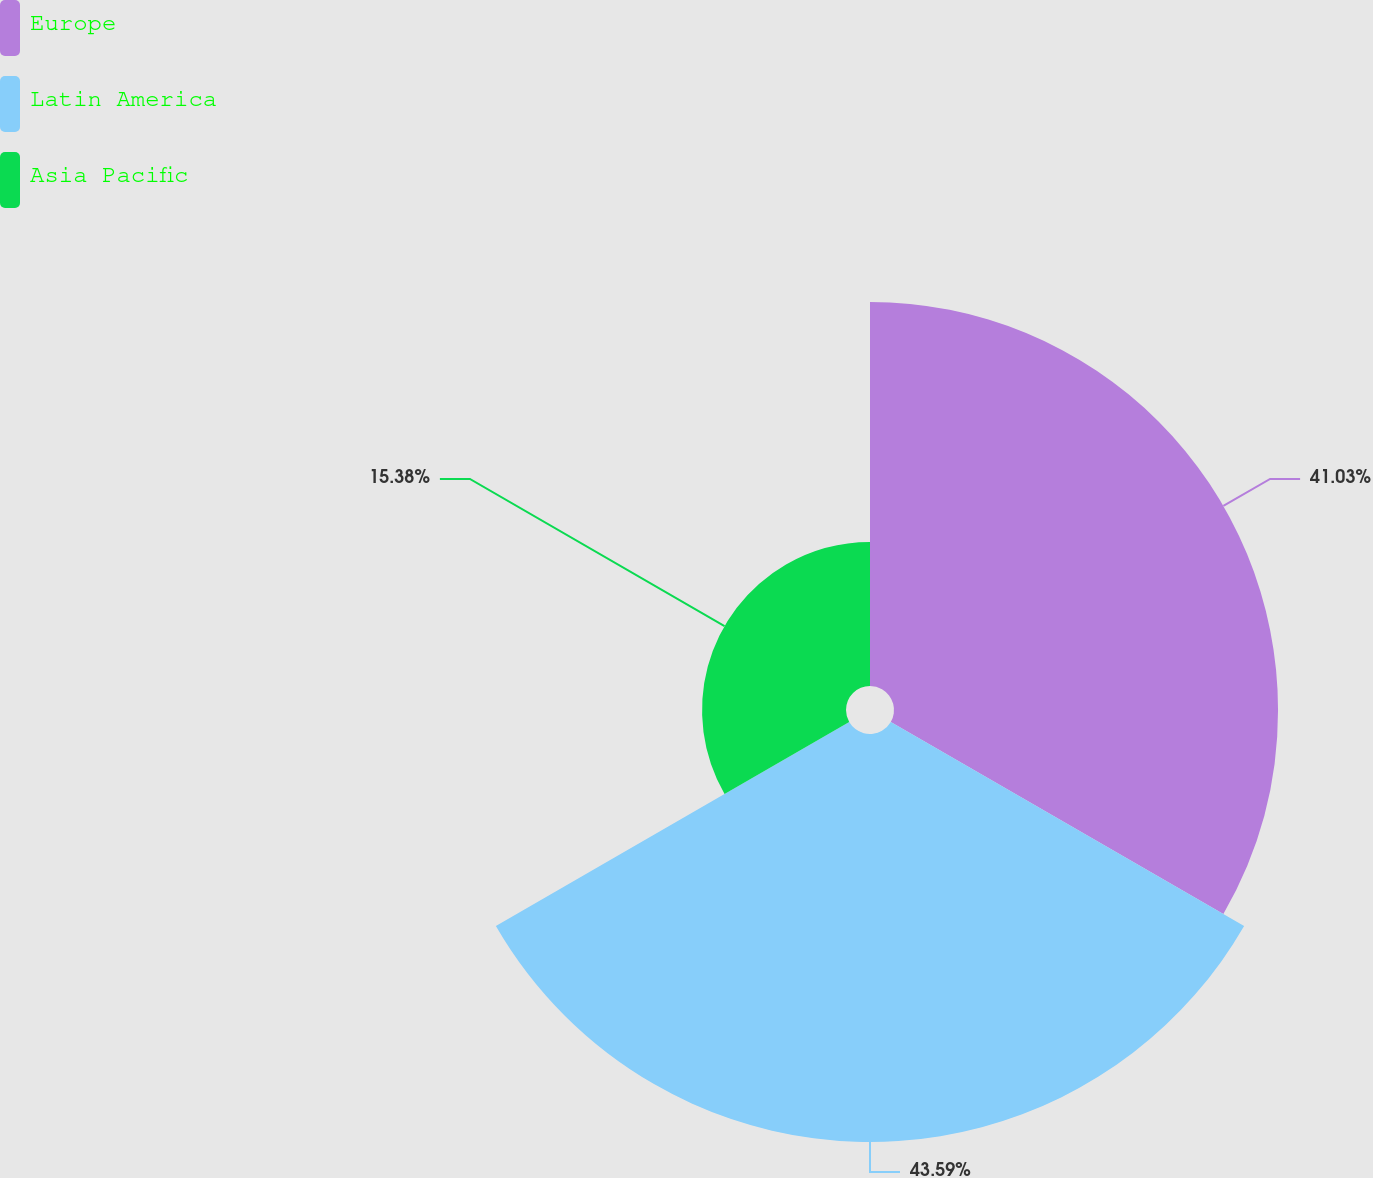Convert chart. <chart><loc_0><loc_0><loc_500><loc_500><pie_chart><fcel>Europe<fcel>Latin America<fcel>Asia Pacific<nl><fcel>41.03%<fcel>43.59%<fcel>15.38%<nl></chart> 